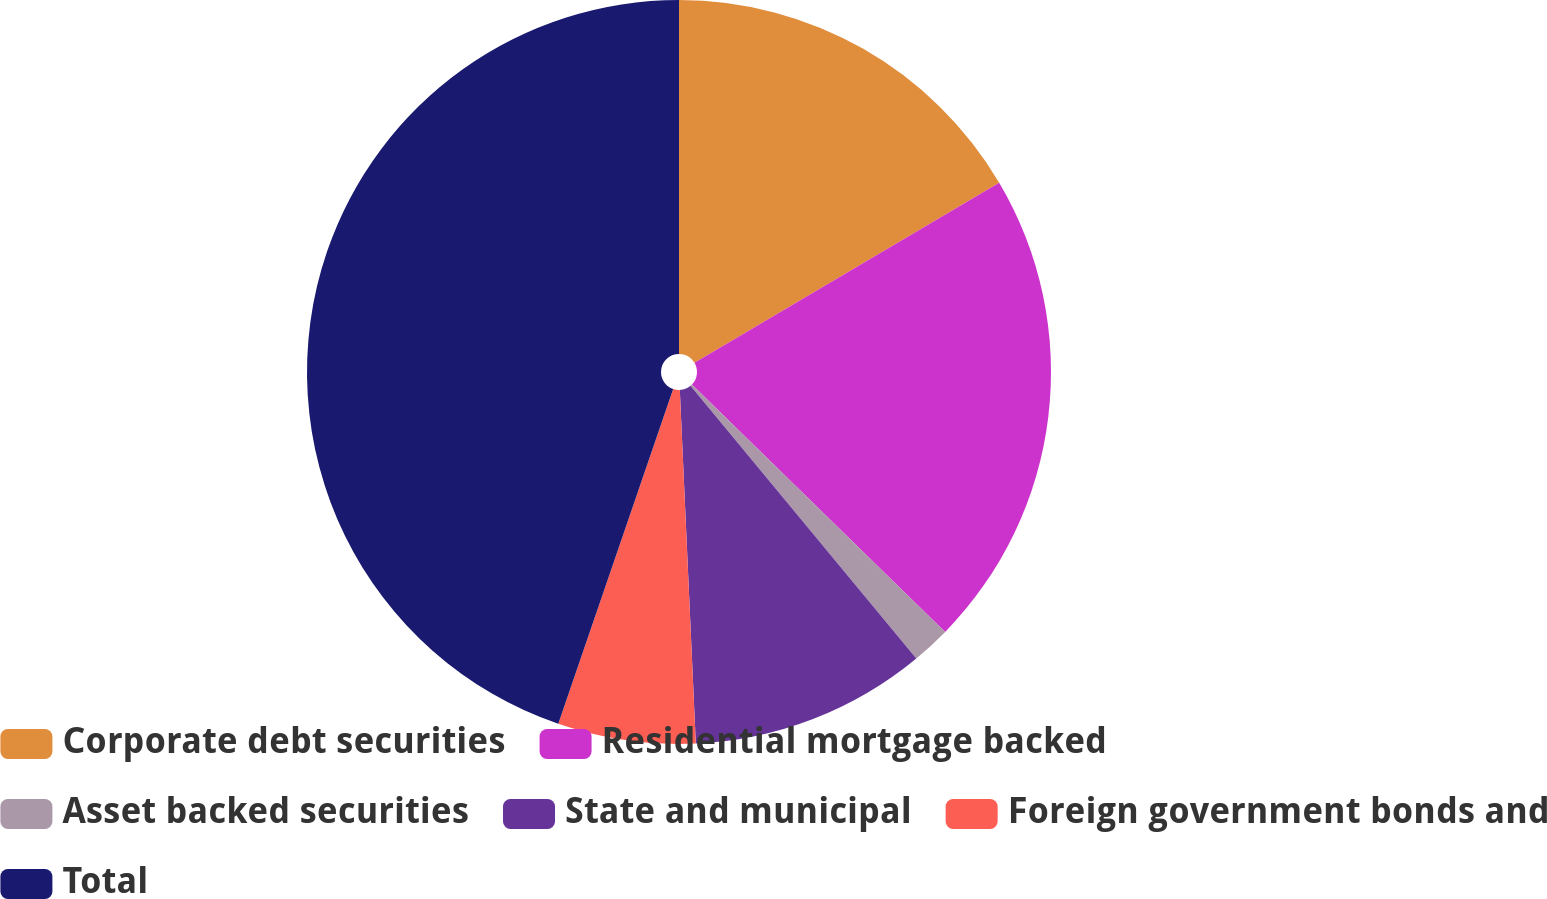<chart> <loc_0><loc_0><loc_500><loc_500><pie_chart><fcel>Corporate debt securities<fcel>Residential mortgage backed<fcel>Asset backed securities<fcel>State and municipal<fcel>Foreign government bonds and<fcel>Total<nl><fcel>16.5%<fcel>20.81%<fcel>1.68%<fcel>10.29%<fcel>5.98%<fcel>44.74%<nl></chart> 